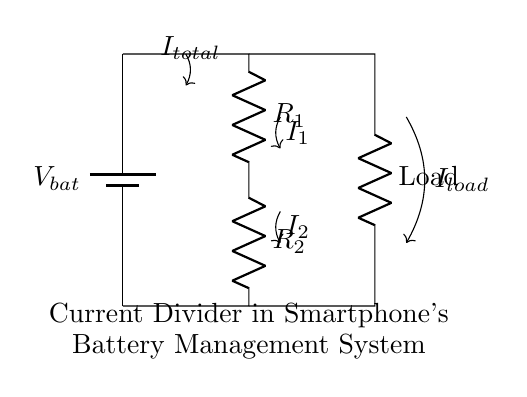What is the total current entering the circuit? The total current is indicated as I_total, which is the current flowing from the battery into the circuit.
Answer: I_total What are the resistances in the circuit? The circuit contains two resistors labeled R_1 and R_2, which are part of the current divider.
Answer: R_1, R_2 What is the direction of current I_1? The direction of current I_1 is from the point between R_1 and R_2 downward, indicating it flows through R_1.
Answer: Downward How does the load affect the current distribution? The load draws current from the junction, and the current distribution will depend on the values of R_1 and R_2, as described by the current divider rule.
Answer: Affects distribution If R_1 equals R_2, what is the relationship between I_1 and I_2? If R_1 equals R_2, by the current divider rule, I_1 and I_2 will be equal as well, meaning they split the total current evenly.
Answer: I_1 = I_2 What happens to I_total when the load resistance decreases? When the load resistance decreases, the total current I_total will increase, as the total resistance decreases, following Ohm's law.
Answer: Increases What is the purpose of the current divider in this circuit? The current divider distributes the total current into multiple paths (through R_1 and R_2) which can supply various components simultaneously within the battery management system.
Answer: Distributes current 